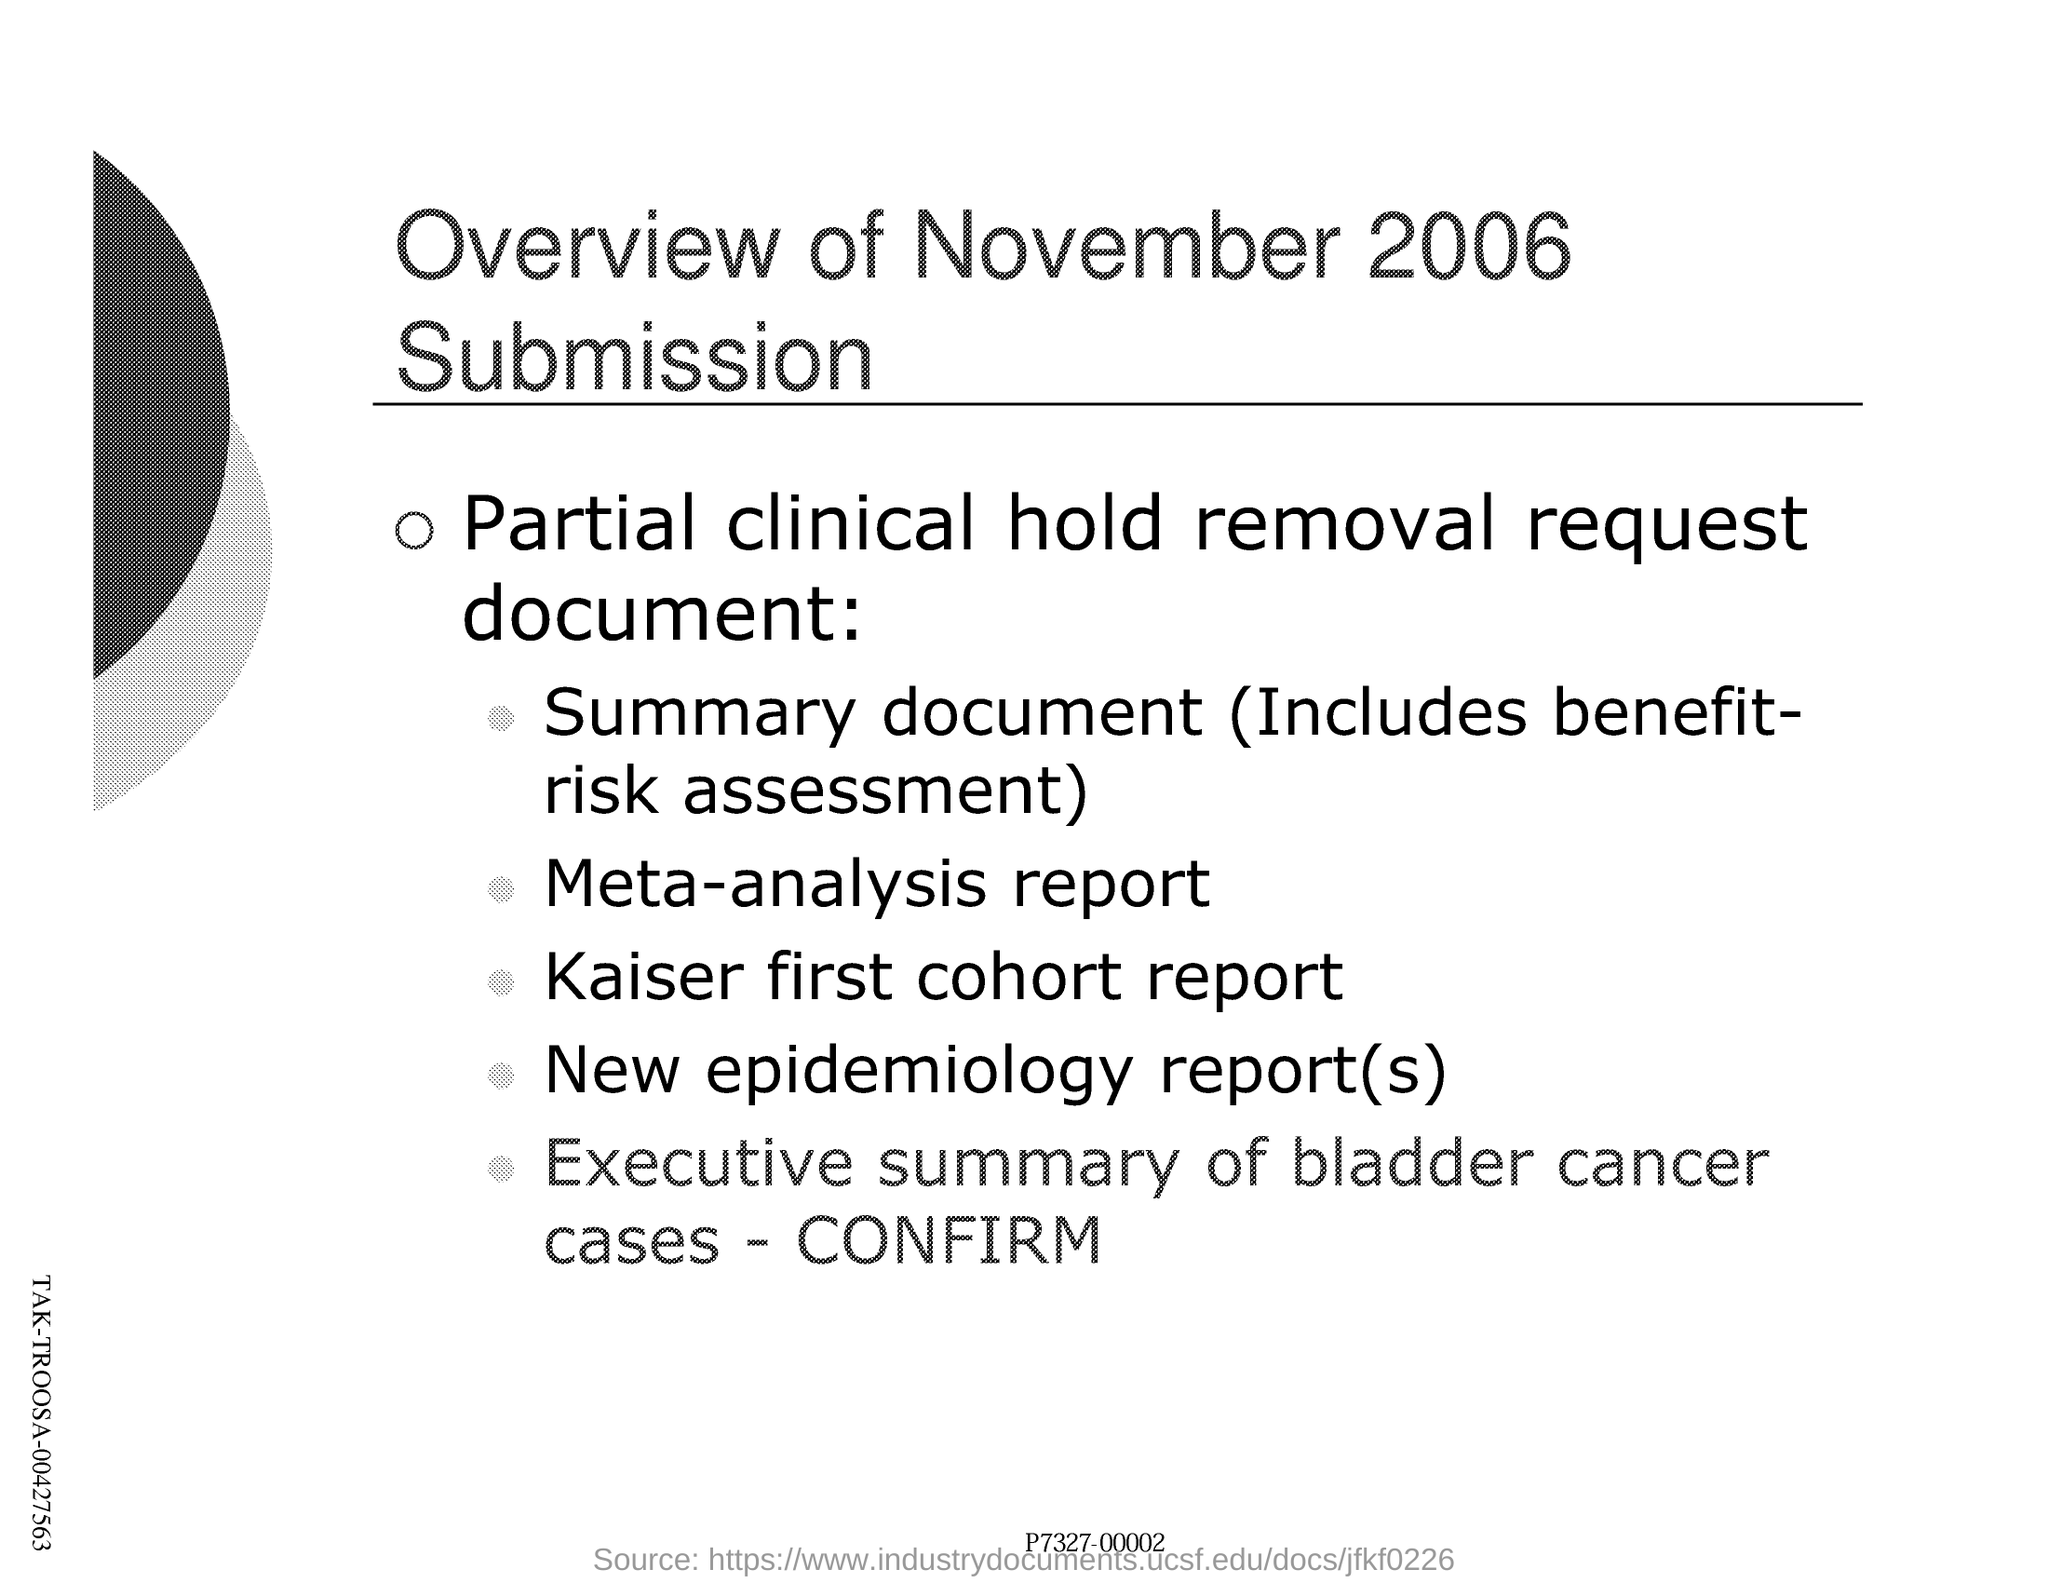Indicate a few pertinent items in this graphic. The summary document includes a benefit-risk assessment. Bladder cancer cases have been confirmed. The request document is titled 'PARTIAL CLINICAL HOLD REMOVAL.' The month and year of the overview of submission is November 2006. 